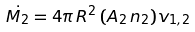<formula> <loc_0><loc_0><loc_500><loc_500>\dot { M _ { 2 } } = 4 \pi \, R ^ { 2 } \, ( A _ { 2 } \, n _ { 2 } ) v _ { 1 , 2 }</formula> 